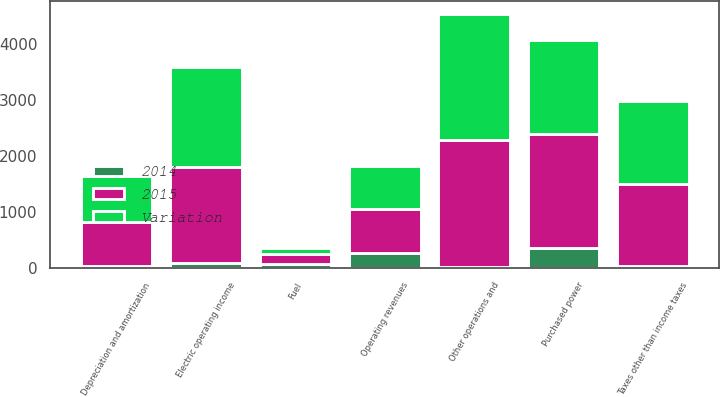<chart> <loc_0><loc_0><loc_500><loc_500><stacked_bar_chart><ecel><fcel>Operating revenues<fcel>Purchased power<fcel>Fuel<fcel>Other operations and<fcel>Depreciation and amortization<fcel>Taxes other than income taxes<fcel>Electric operating income<nl><fcel>Variation<fcel>781<fcel>1684<fcel>118<fcel>2259<fcel>820<fcel>1493<fcel>1798<nl><fcel>2015<fcel>781<fcel>2036<fcel>180<fcel>2270<fcel>781<fcel>1458<fcel>1712<nl><fcel>2014<fcel>265<fcel>352<fcel>62<fcel>11<fcel>39<fcel>35<fcel>86<nl></chart> 